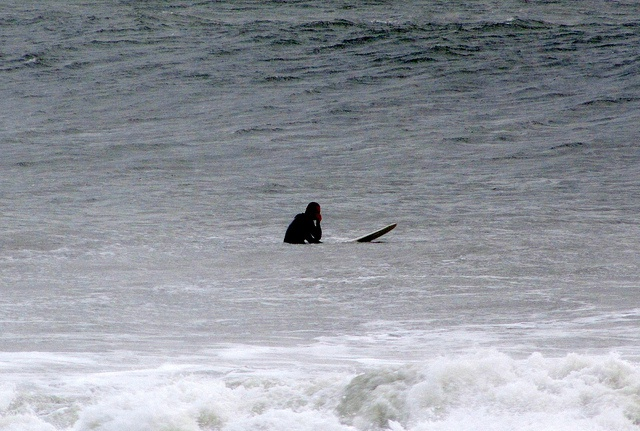Describe the objects in this image and their specific colors. I can see people in gray, black, darkgray, and maroon tones and surfboard in gray, black, darkgray, and lightgray tones in this image. 